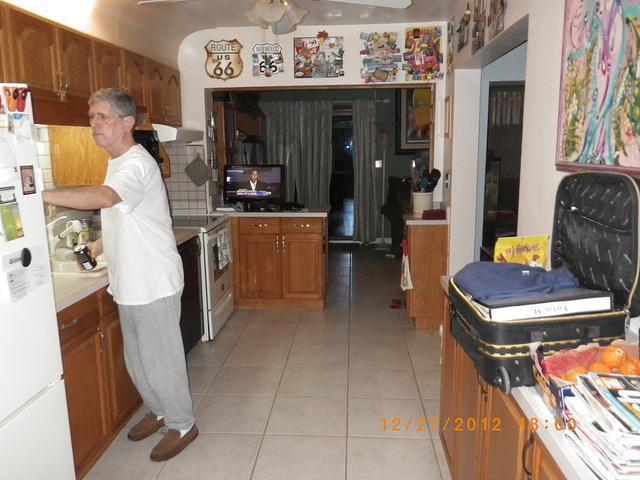How many people are present?
Give a very brief answer. 1. How many books are in the photo?
Give a very brief answer. 2. How many tvs are visible?
Give a very brief answer. 1. How many refrigerators are in the picture?
Give a very brief answer. 1. 